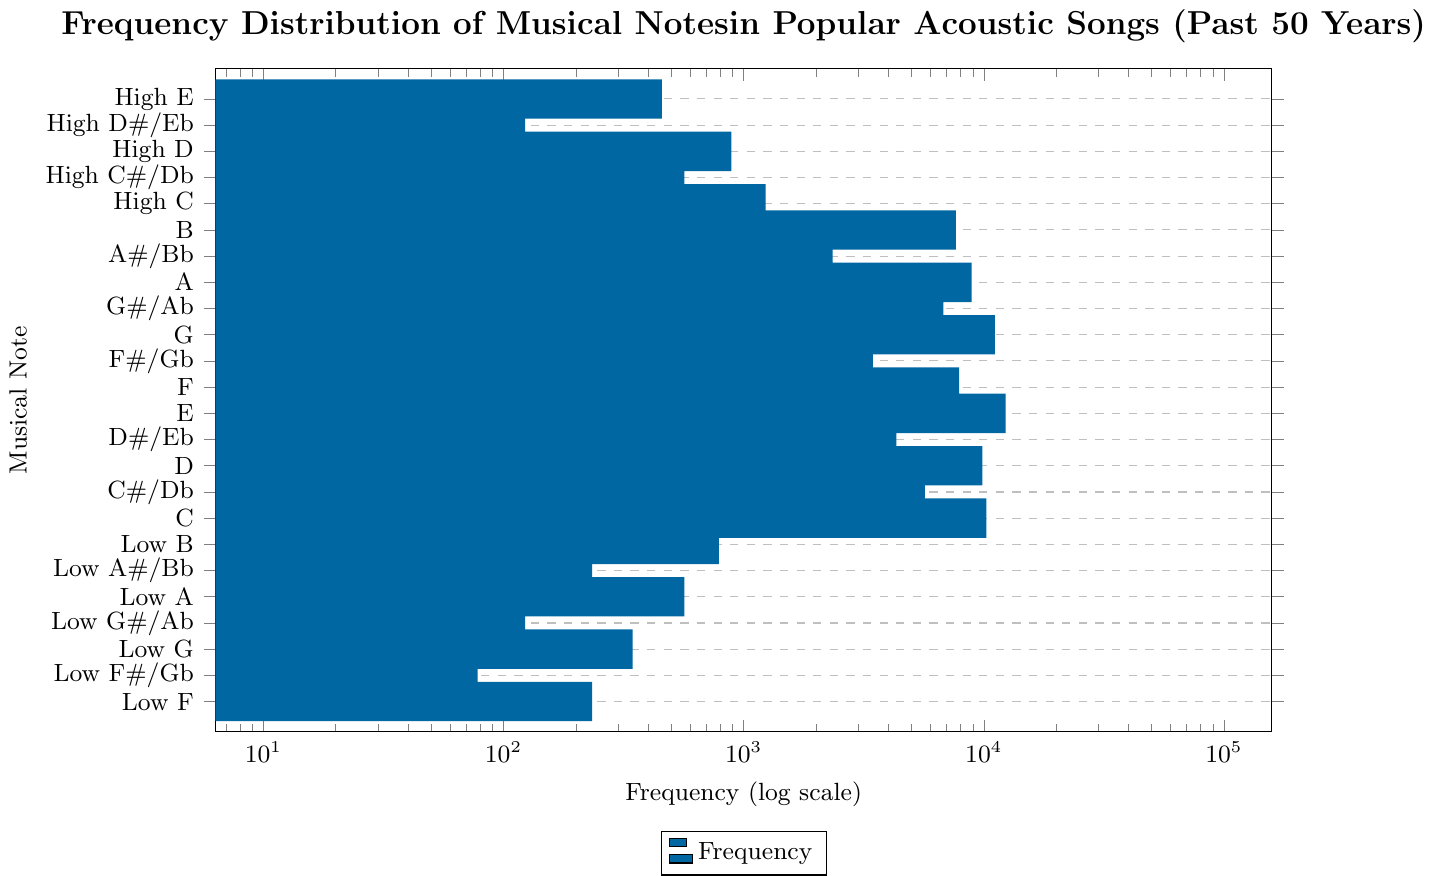What is the frequency of the note with the highest occurrence? The note with the highest occurrence can be identified by finding the tallest bar. The tallest bar corresponds to the E note, with a frequency of 12,345.
Answer: 12,345 Which note has a lower frequency, F#/Gb or C#/Db? To compare, find the bars corresponding to F#/Gb and C#/Db. The bar for F#/Gb has a frequency of 3,456, and C#/Db has a frequency of 5,678. Since 3,456 is less than 5,678, F#/Gb has a lower frequency.
Answer: F#/Gb What is the median frequency value among all the notes? Sort the frequencies in ascending order: 78, 123, 123, 234, 234, 345, 456, 567, 567, 789, 890, 1234, 2345, 3456, 4321, 5678, 6789, 7654, 7890, 8901, 9876, 10245, 11111, 12345. Since there are 24 notes, the median is the average of the 12th and 13th frequencies. The 12th frequency is 1234 and the 13th is 2345, so the median is (1234 + 2345) / 2 = 1789.5.
Answer: 1789.5 How many notes have a frequency greater than 5,000? Count the frequencies above 5,000: 5,678, 9,876, 12,345, 7,890, 3,456, 11,111, 6,789, 8,901, 7,654, and 10,245. There are 10 notes with frequencies greater than 5,000.
Answer: 10 Which note has the lowest frequency, and what is its value? The note with the lowest frequency corresponds to the shortest bar. The shortest bar represents the Low F#/Gb note with a frequency of 78.
Answer: Low F#/Gb, 78 Is the frequency of G#/Ab higher or lower than the average frequency of all notes? Calculate the average frequency first. Sum all frequencies: (234 + 78 + 345 + 123 + 567 + 234 + 789 + 10245 + 5678 + 9876 + 4321 + 12345 + 7890 + 3456 + 11111 + 6789 + 8901 + 2345 + 7654 + 1234 + 567 + 890 + 123 + 456) = 104016. Divide by the number of notes (24): 104016 / 24 ≈ 4334. The frequency of G#/Ab is 6,789, which is higher than the average frequency of 4,334.
Answer: Higher Between the notes A and High C, which has a higher frequency and by how much? Compare the frequencies of A and High C. A has a frequency of 8,901, and High C has a frequency of 1,234. The difference is 8,901 - 1,234 = 7,667. A has the higher frequency by 7,667.
Answer: A, 7,667 How many notes are labeled as "high" in the plot and what are their frequencies? Identify the notes labeled as "high": High C (1,234), High C#/Db (567), High D (890), High D#/Eb (123), and High E (456). There are 5 high notes.
Answer: 5 notes: 1,234, 567, 890, 123, 456 